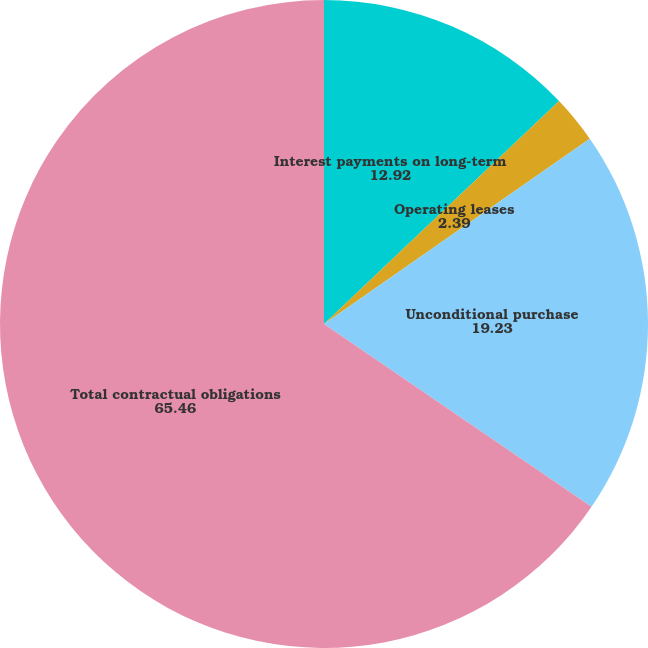Convert chart to OTSL. <chart><loc_0><loc_0><loc_500><loc_500><pie_chart><fcel>Interest payments on long-term<fcel>Operating leases<fcel>Unconditional purchase<fcel>Total contractual obligations<nl><fcel>12.92%<fcel>2.39%<fcel>19.23%<fcel>65.46%<nl></chart> 